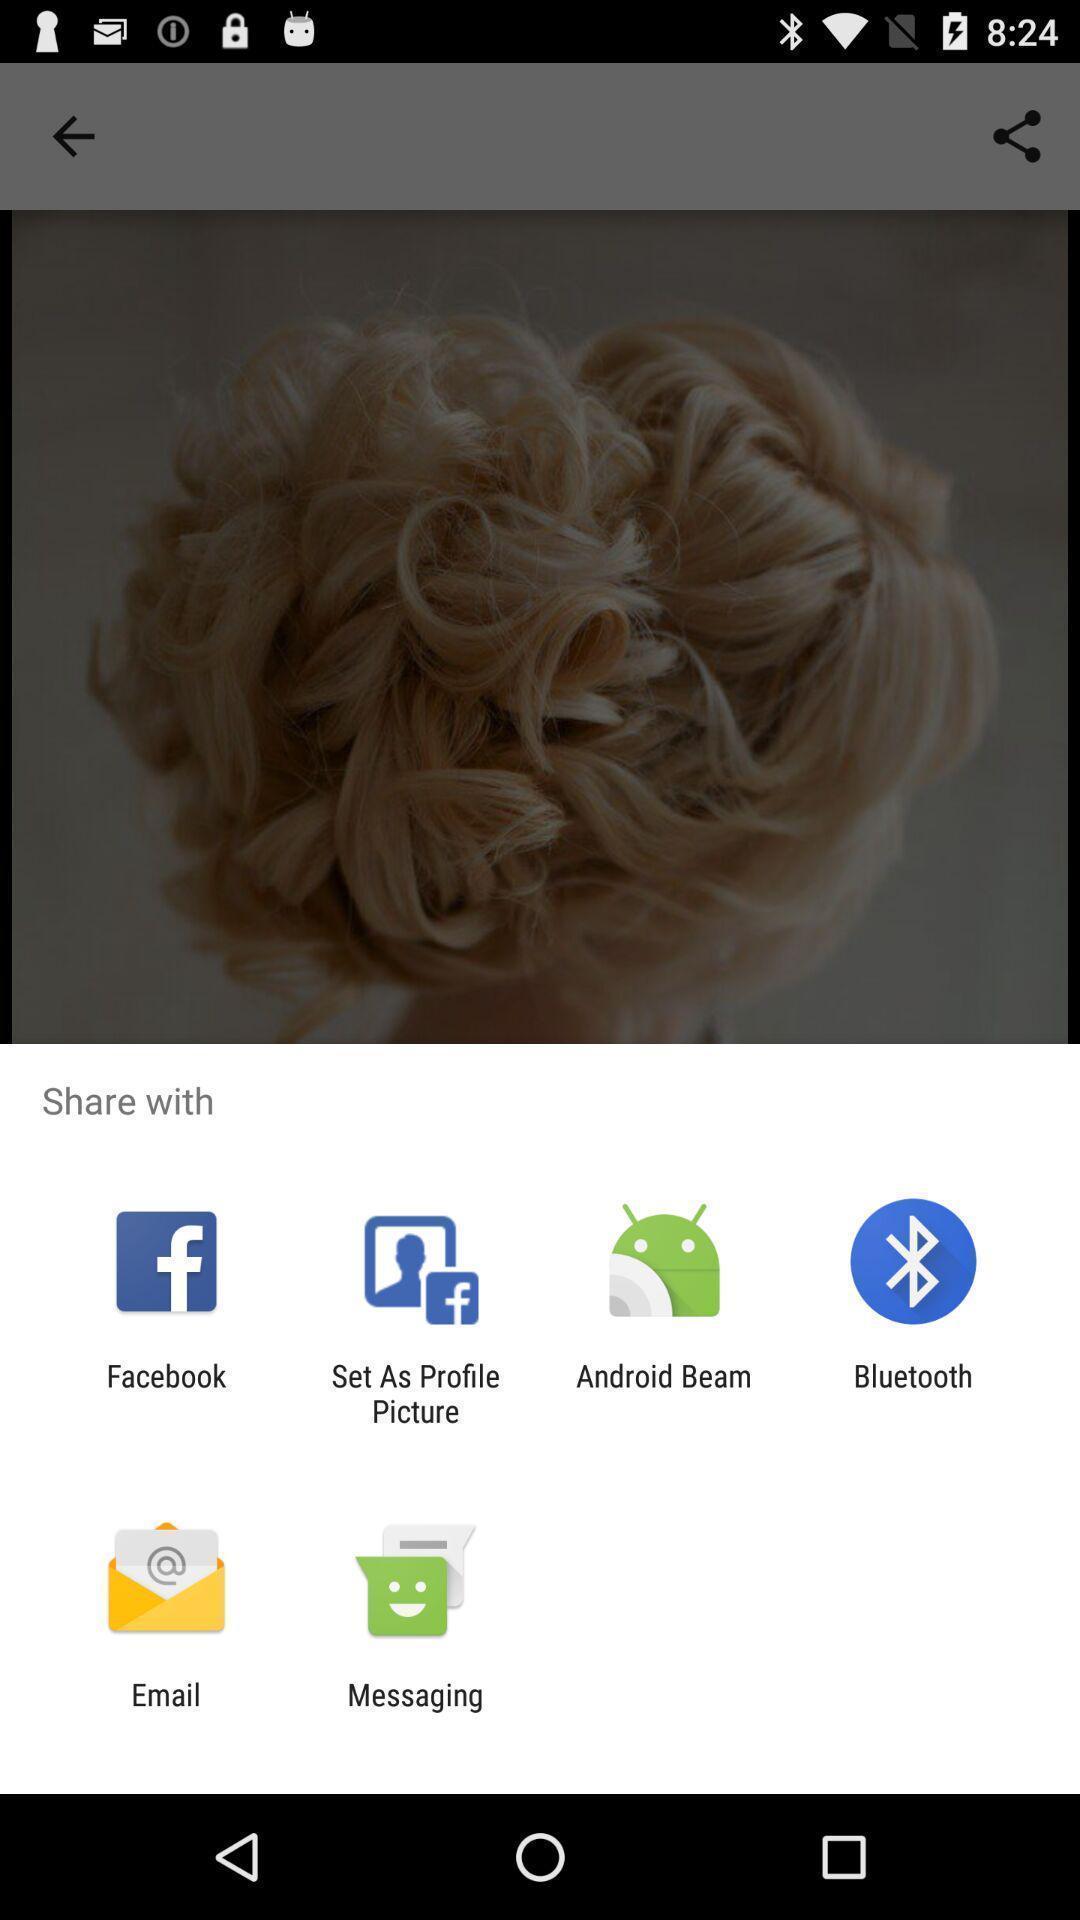Describe the content in this image. Pop-up shows to share with multiple applications. 